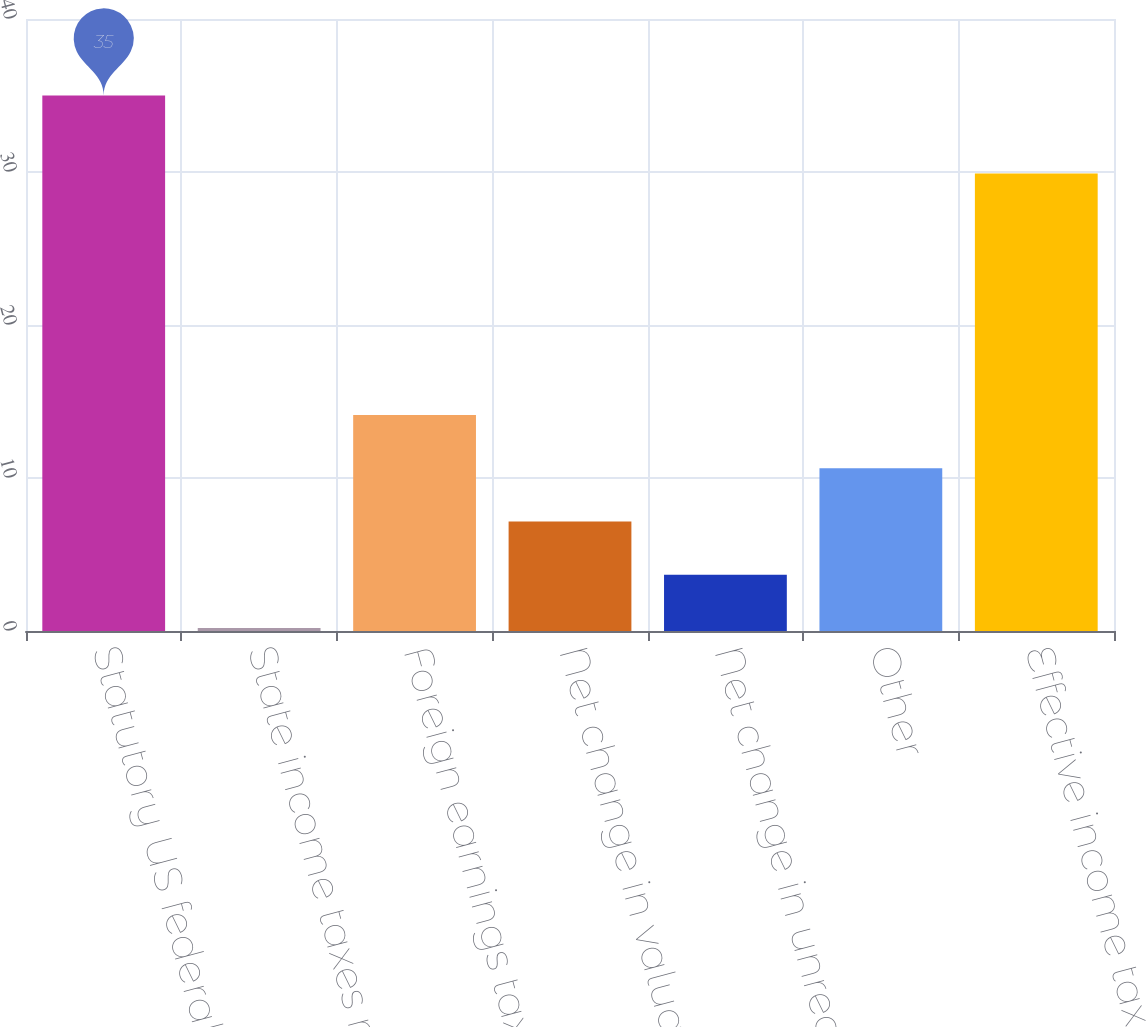<chart> <loc_0><loc_0><loc_500><loc_500><bar_chart><fcel>Statutory US federal tax rate<fcel>State income taxes net of<fcel>Foreign earnings taxed at<fcel>Net change in valuation<fcel>Net change in unrecognized tax<fcel>Other<fcel>Effective income tax rate<nl><fcel>35<fcel>0.2<fcel>14.12<fcel>7.16<fcel>3.68<fcel>10.64<fcel>29.9<nl></chart> 